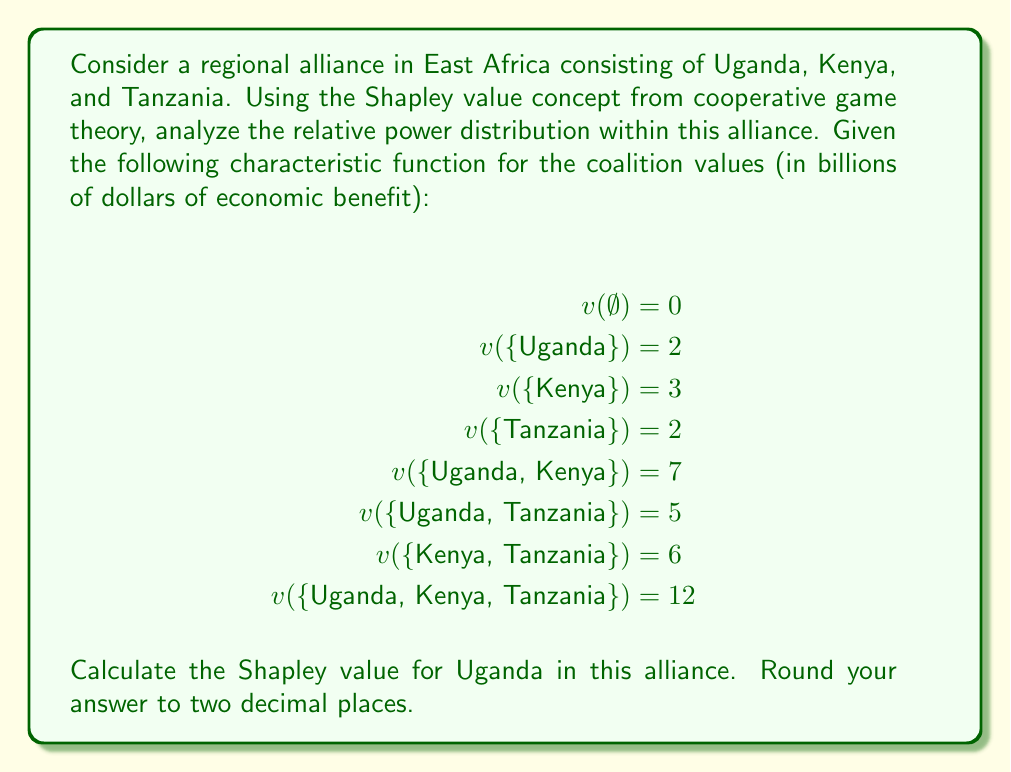Provide a solution to this math problem. To calculate the Shapley value for Uganda, we need to consider all possible coalition formations and Uganda's marginal contribution to each.

The Shapley value formula is:

$$\phi_i(v) = \sum_{S \subseteq N \setminus \{i\}} \frac{|S|!(n-|S|-1)!}{n!}[v(S \cup \{i\}) - v(S)]$$

Where:
$N$ is the set of all players
$n$ is the total number of players
$S$ is a subset of players not including player $i$
$v(S)$ is the characteristic function

For Uganda (U), we need to calculate:

1. U joins empty coalition: $v(\{U\}) - v(\emptyset) = 2 - 0 = 2$
2. U joins K: $v(\{U,K\}) - v(\{K\}) = 7 - 3 = 4$
3. U joins T: $v(\{U,T\}) - v(\{T\}) = 5 - 2 = 3$
4. U joins KT: $v(\{U,K,T\}) - v(\{K,T\}) = 12 - 6 = 6$

Now, we apply the formula:

$$\begin{align*}
\phi_U(v) &= \frac{2!0!}{3!}(2) + \frac{1!1!}{3!}(4) + \frac{1!1!}{3!}(3) + \frac{0!2!}{3!}(6) \\
&= \frac{1}{3}(2) + \frac{1}{6}(4) + \frac{1}{6}(3) + \frac{1}{3}(6) \\
&= \frac{2}{3} + \frac{2}{3} + \frac{1}{2} + 2 \\
&= 3.8333...
\end{align*}$$

Rounding to two decimal places gives us 3.83.
Answer: $3.83$ 